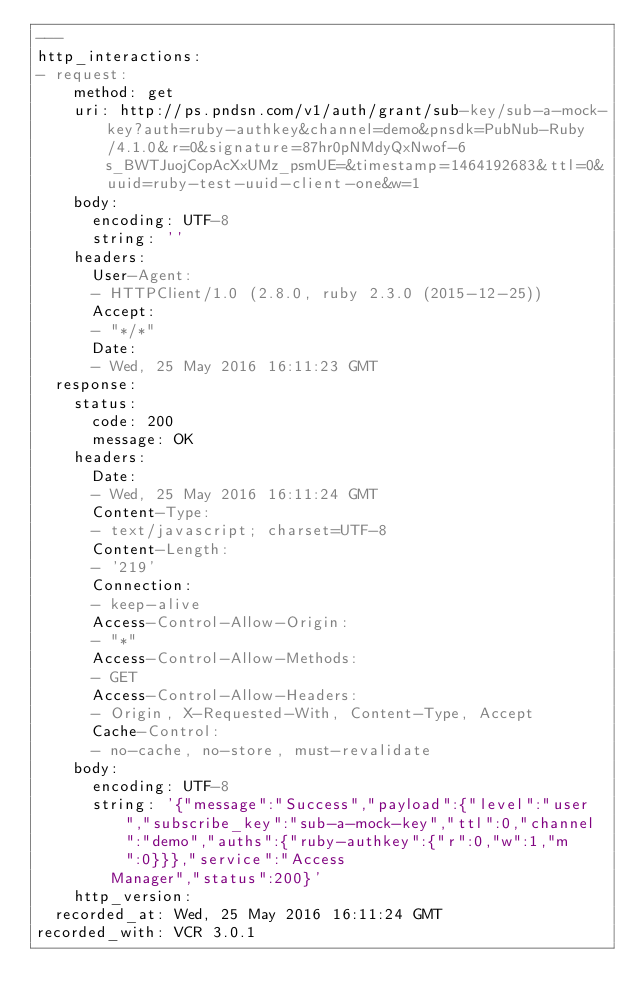Convert code to text. <code><loc_0><loc_0><loc_500><loc_500><_YAML_>---
http_interactions:
- request:
    method: get
    uri: http://ps.pndsn.com/v1/auth/grant/sub-key/sub-a-mock-key?auth=ruby-authkey&channel=demo&pnsdk=PubNub-Ruby/4.1.0&r=0&signature=87hr0pNMdyQxNwof-6s_BWTJuojCopAcXxUMz_psmUE=&timestamp=1464192683&ttl=0&uuid=ruby-test-uuid-client-one&w=1
    body:
      encoding: UTF-8
      string: ''
    headers:
      User-Agent:
      - HTTPClient/1.0 (2.8.0, ruby 2.3.0 (2015-12-25))
      Accept:
      - "*/*"
      Date:
      - Wed, 25 May 2016 16:11:23 GMT
  response:
    status:
      code: 200
      message: OK
    headers:
      Date:
      - Wed, 25 May 2016 16:11:24 GMT
      Content-Type:
      - text/javascript; charset=UTF-8
      Content-Length:
      - '219'
      Connection:
      - keep-alive
      Access-Control-Allow-Origin:
      - "*"
      Access-Control-Allow-Methods:
      - GET
      Access-Control-Allow-Headers:
      - Origin, X-Requested-With, Content-Type, Accept
      Cache-Control:
      - no-cache, no-store, must-revalidate
    body:
      encoding: UTF-8
      string: '{"message":"Success","payload":{"level":"user","subscribe_key":"sub-a-mock-key","ttl":0,"channel":"demo","auths":{"ruby-authkey":{"r":0,"w":1,"m":0}}},"service":"Access
        Manager","status":200}'
    http_version: 
  recorded_at: Wed, 25 May 2016 16:11:24 GMT
recorded_with: VCR 3.0.1
</code> 